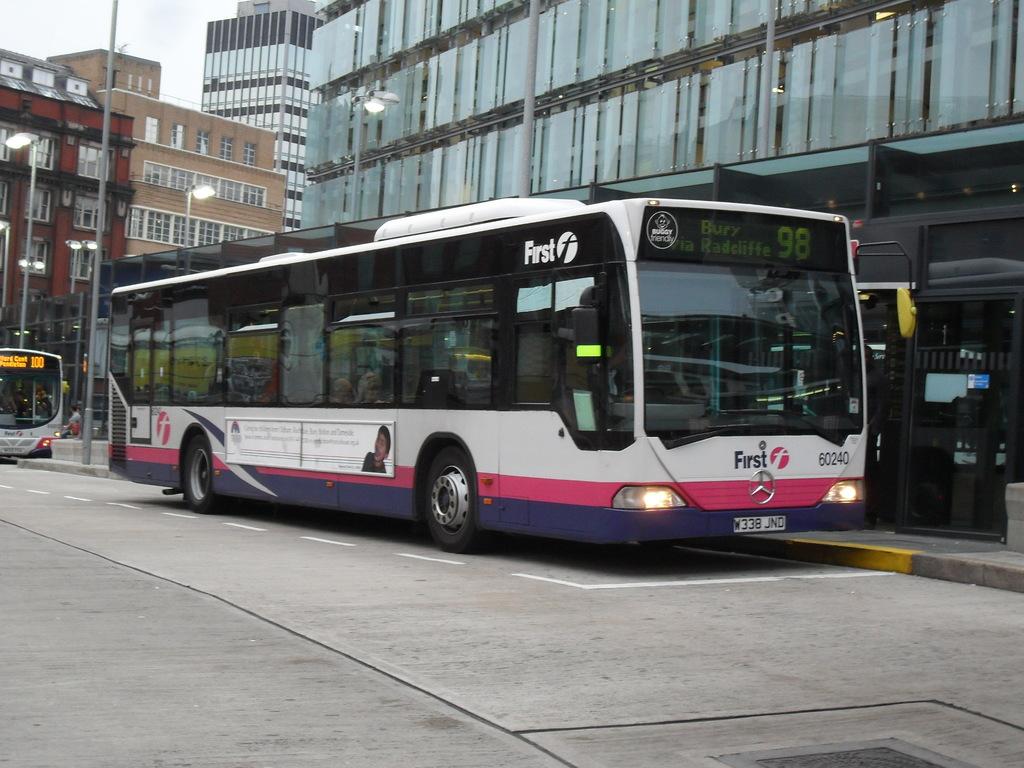What is this buses number?
Ensure brevity in your answer.  98. What is the number of the bus?
Provide a succinct answer. 98. 